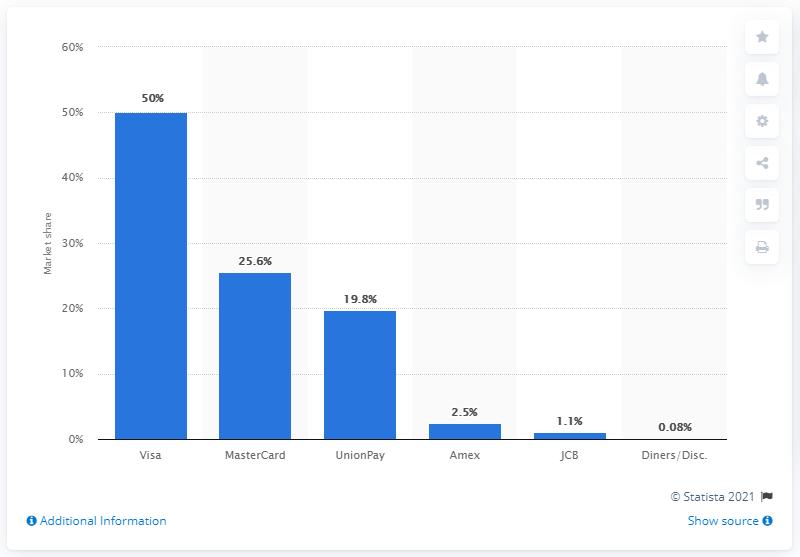Draw attention to some important aspects in this diagram. In 2017, MasterCard held a market share of 25.6% of the global credit card market. 